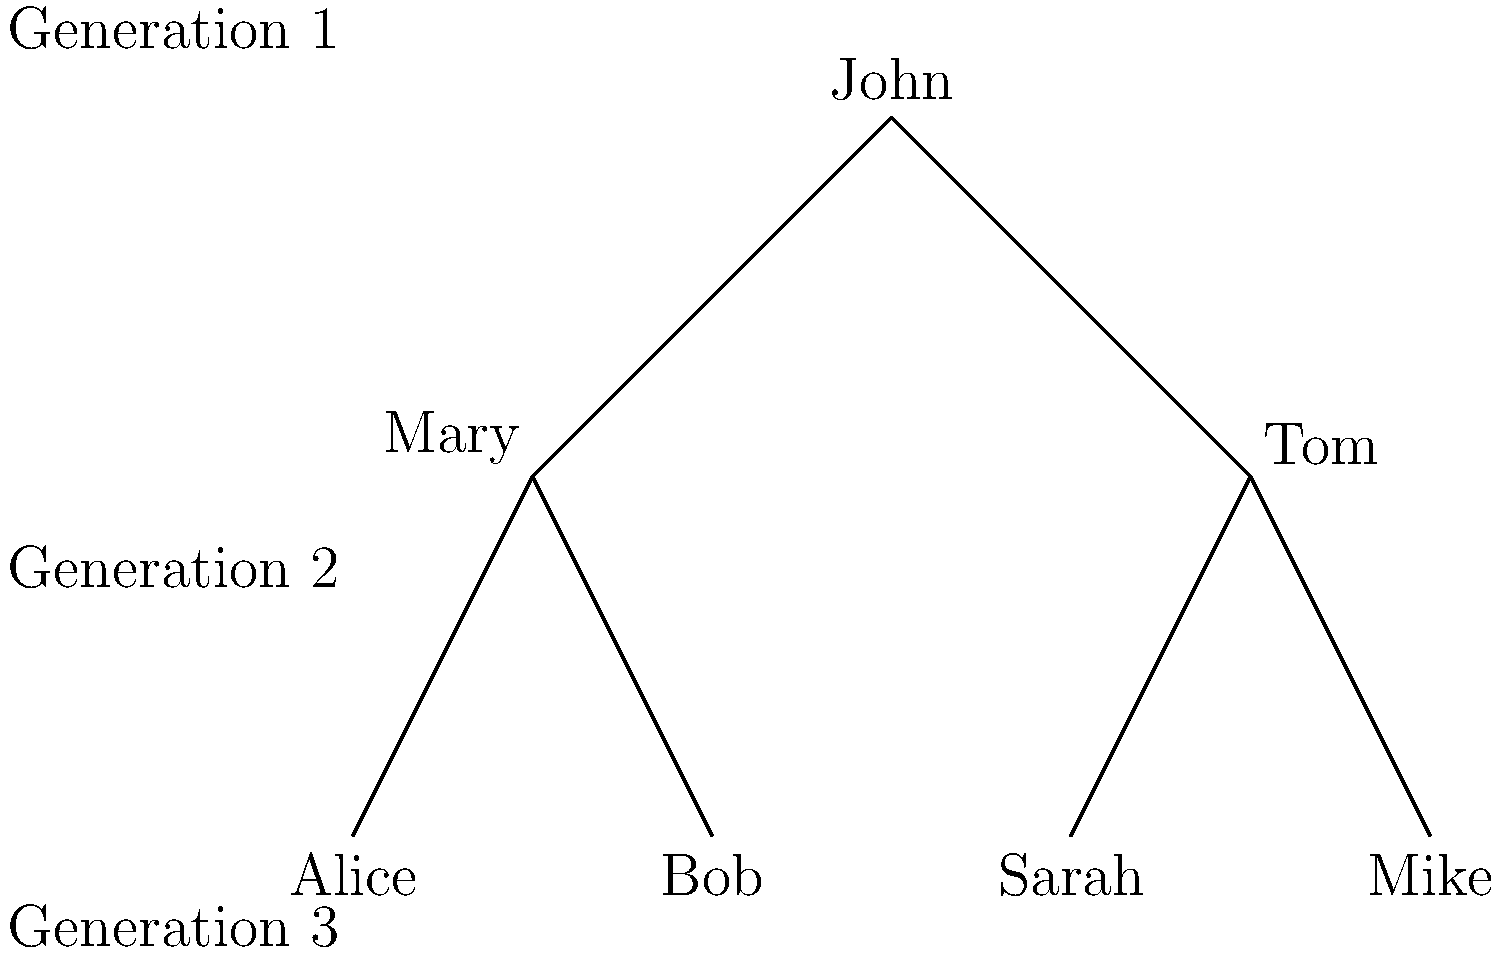In the context of tracing a missing family member, how many potential avenues of investigation does this family tree provide for locating John's grandchildren, assuming all individuals shown are still living? To answer this question, we need to analyze the family tree and identify John's grandchildren. Let's break it down step-by-step:

1. Identify John's children:
   - John is at the top of the family tree (Generation 1).
   - He has two children in Generation 2: Mary and Tom.

2. Identify John's grandchildren:
   - Mary has two children: Alice and Bob (Generation 3).
   - Tom has two children: Sarah and Mike (Generation 3).
   - All four individuals in Generation 3 are John's grandchildren.

3. Count the potential avenues of investigation:
   - Each grandchild represents a potential avenue of investigation.
   - There are four grandchildren: Alice, Bob, Sarah, and Mike.

4. Consider the context of tracing a missing family member:
   - In a real investigation, each of these grandchildren could provide valuable information or leads.
   - They might have different levels of contact with other family members or different knowledge about family history.

5. Assume all individuals are living:
   - This assumption means that all four grandchildren are potential sources of information.

Therefore, this family tree provides 4 potential avenues of investigation for locating John's grandchildren. Each grandchild could be contacted or researched separately in the process of tracing a missing family member.
Answer: 4 avenues 